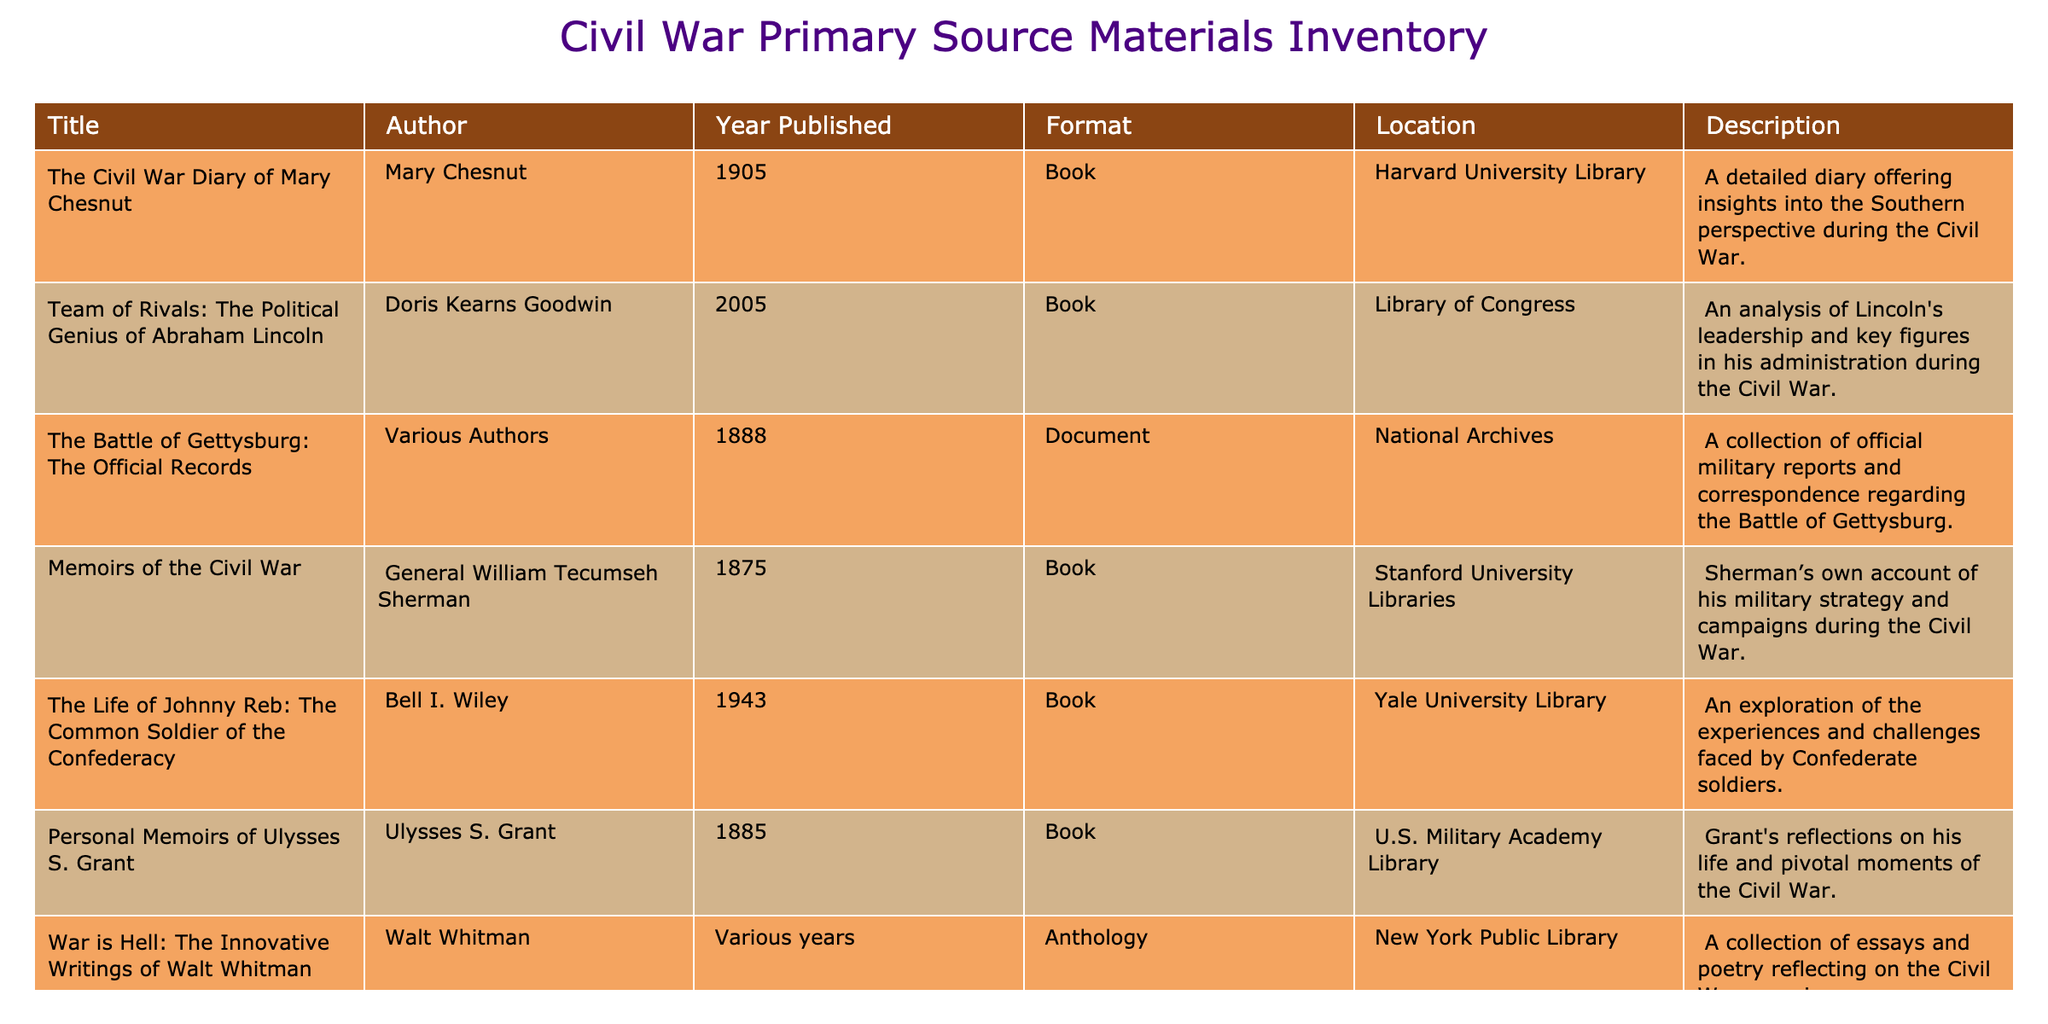What is the title of the book authored by Mary Chesnut? The table shows that the book titled "The Civil War Diary of Mary Chesnut" is authored by Mary Chesnut.
Answer: "The Civil War Diary of Mary Chesnut" How many documents are listed in the inventory? The table indicates there is one document, titled "The Battle of Gettysburg: The Official Records," categorized under the format 'Document.'
Answer: 1 Which library holds "The Life of Johnny Reb: The Common Soldier of the Confederacy"? By checking the "Location" column, it is clear that Yale University Library is the holding institution for "The Life of Johnny Reb: The Common Soldier of the Confederacy."
Answer: Yale University Library Is "Memoirs of the Civil War" written by a General? The table lists "Memoirs of the Civil War" with General William Tecumseh Sherman as the author, confirming it is indeed written by a General.
Answer: Yes What is the range of years during which the books in this inventory were published? The earliest publication year is 1875 (for “Memoirs of the Civil War”) and the latest is 2005 (for “Team of Rivals”), resulting in a range from 1875 to 2005.
Answer: 1875 to 2005 How many works listed in the table were published before 1900? From the table, we identify three works (published in 1875, 1884-1887, and 1888) that were published before 1900. Counting these entries gives us a total of 3.
Answer: 3 What is the most recent publication year for any of the materials listed? In reviewing the "Year Published" column, "Team of Rivals: The Political Genius of Abraham Lincoln" is published in 2005, which is the most recent year listed.
Answer: 2005 Can you identify whether "War is Hell: The Innovative Writings of Walt Whitman" includes multiple authors? The author column specifies "Walt Whitman" but states "Various years," indicating that this anthology may compile works from multiple years, suggesting contributions from various individuals, but it is attributed to Whitman.
Answer: No Which title provides the Southern perspective during the Civil War? Analyzing the "Description" column, "The Civil War Diary of Mary Chesnut" explicitly states it offers insights into the Southern perspective during the Civil War.
Answer: "The Civil War Diary of Mary Chesnut" 